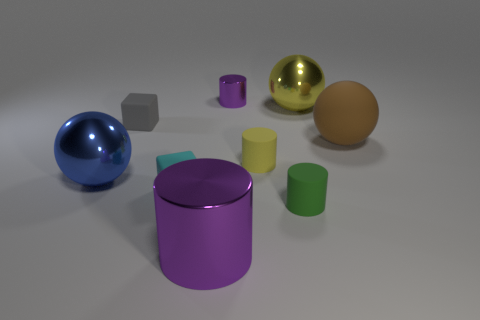Subtract all red spheres. Subtract all gray cubes. How many spheres are left? 3 Subtract all red balls. How many brown blocks are left? 0 Add 5 reds. How many small greens exist? 0 Subtract all tiny green rubber cylinders. Subtract all tiny gray things. How many objects are left? 7 Add 4 metal objects. How many metal objects are left? 8 Add 2 blue things. How many blue things exist? 3 Add 1 blue shiny things. How many objects exist? 10 Subtract all yellow balls. How many balls are left? 2 Subtract all large cylinders. How many cylinders are left? 3 Subtract 0 red cubes. How many objects are left? 9 